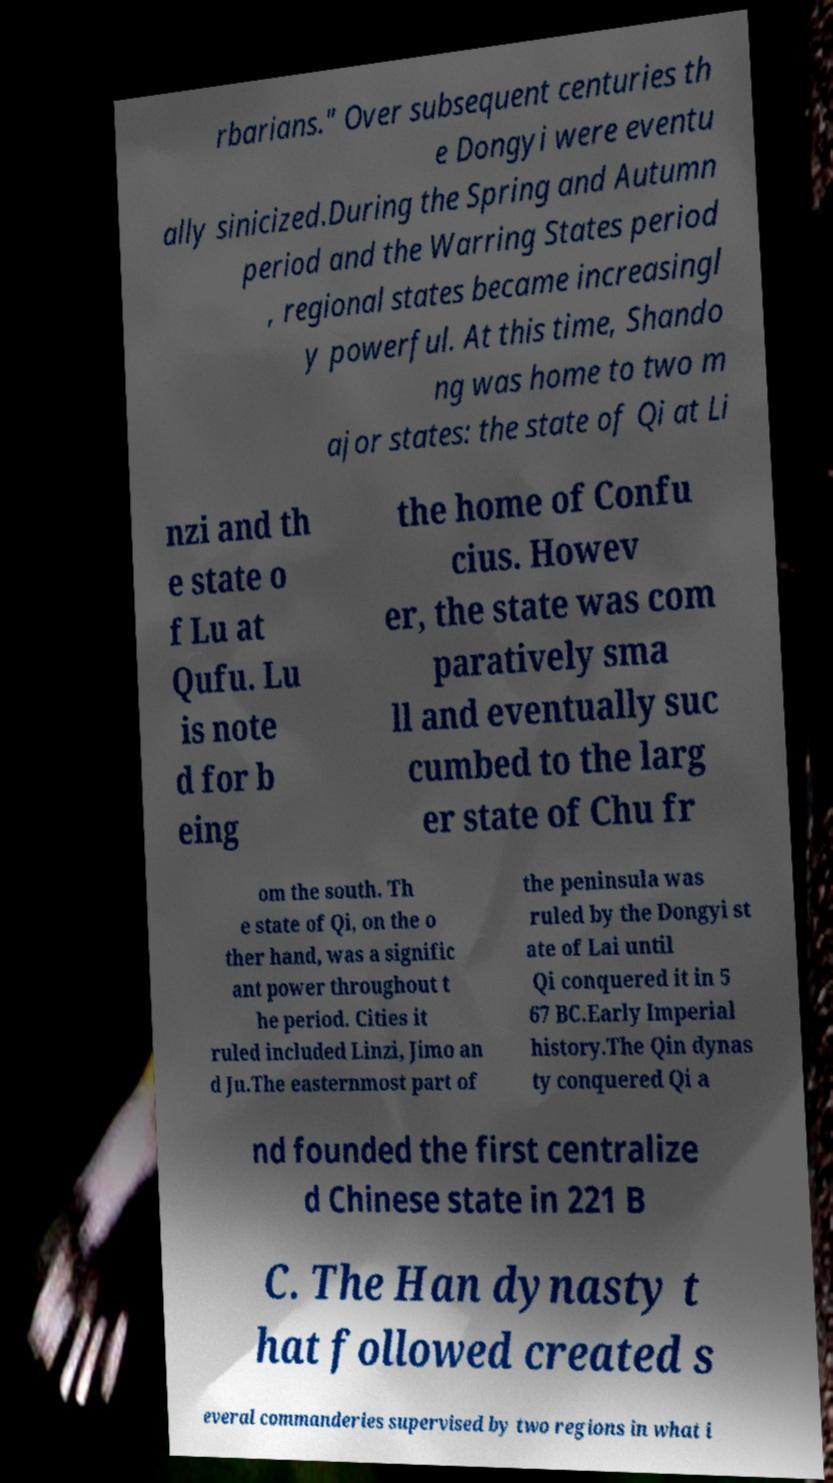For documentation purposes, I need the text within this image transcribed. Could you provide that? rbarians." Over subsequent centuries th e Dongyi were eventu ally sinicized.During the Spring and Autumn period and the Warring States period , regional states became increasingl y powerful. At this time, Shando ng was home to two m ajor states: the state of Qi at Li nzi and th e state o f Lu at Qufu. Lu is note d for b eing the home of Confu cius. Howev er, the state was com paratively sma ll and eventually suc cumbed to the larg er state of Chu fr om the south. Th e state of Qi, on the o ther hand, was a signific ant power throughout t he period. Cities it ruled included Linzi, Jimo an d Ju.The easternmost part of the peninsula was ruled by the Dongyi st ate of Lai until Qi conquered it in 5 67 BC.Early Imperial history.The Qin dynas ty conquered Qi a nd founded the first centralize d Chinese state in 221 B C. The Han dynasty t hat followed created s everal commanderies supervised by two regions in what i 